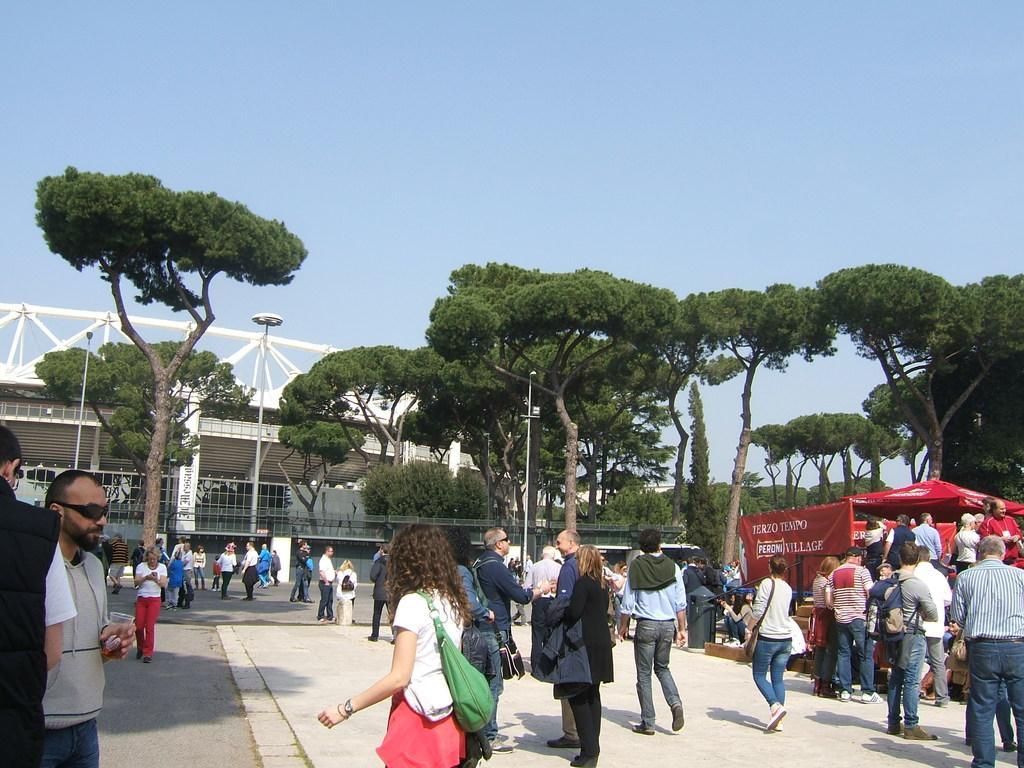Please provide a concise description of this image. In this image I can see few people some are standing and some are walking, in front the person is wearing white shirt, red short and green color bag. Background I can see a tent in red color, a building in white color, trees in green color and the sky is in blue color. 